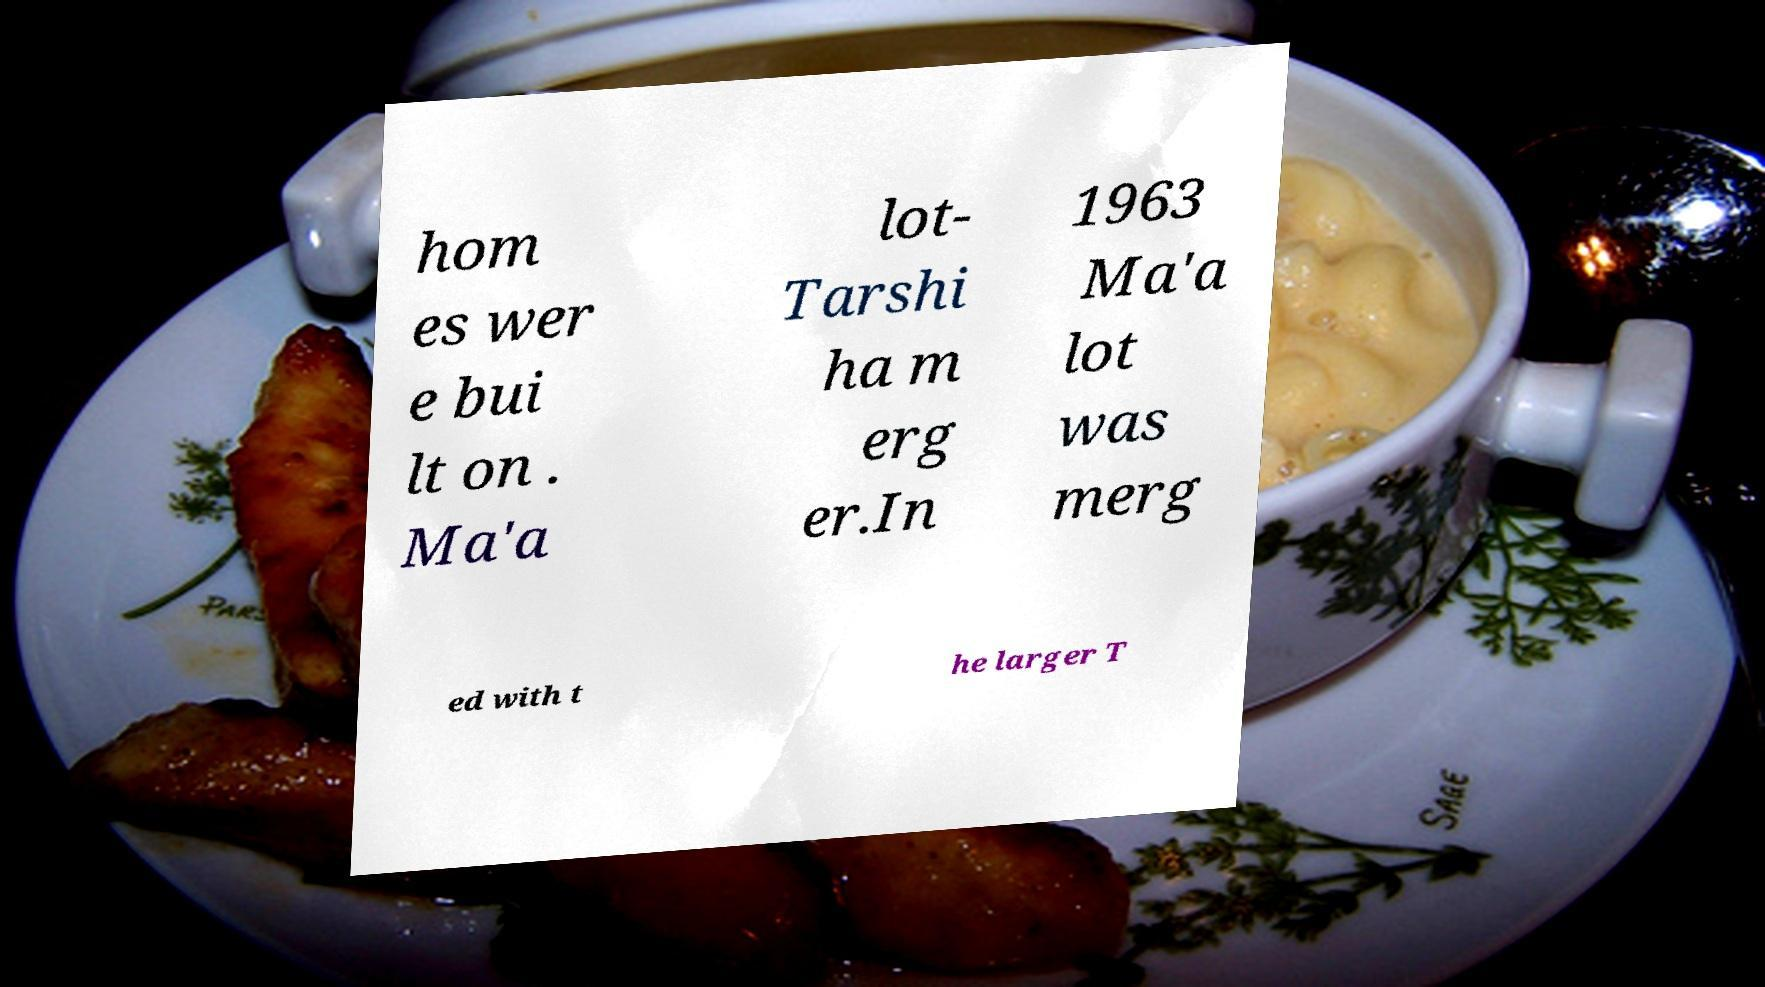Can you read and provide the text displayed in the image?This photo seems to have some interesting text. Can you extract and type it out for me? hom es wer e bui lt on . Ma'a lot- Tarshi ha m erg er.In 1963 Ma'a lot was merg ed with t he larger T 